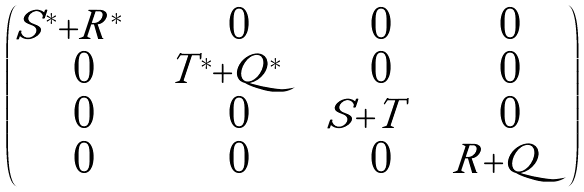<formula> <loc_0><loc_0><loc_500><loc_500>\begin{pmatrix} | S ^ { * } | + | R ^ { * } | & 0 & 0 & 0 \\ 0 & | T ^ { * } | + | Q ^ { * } | & 0 & 0 \\ 0 & 0 & | S | + | T | & 0 \\ 0 & 0 & 0 & | R | + | Q | \end{pmatrix}</formula> 